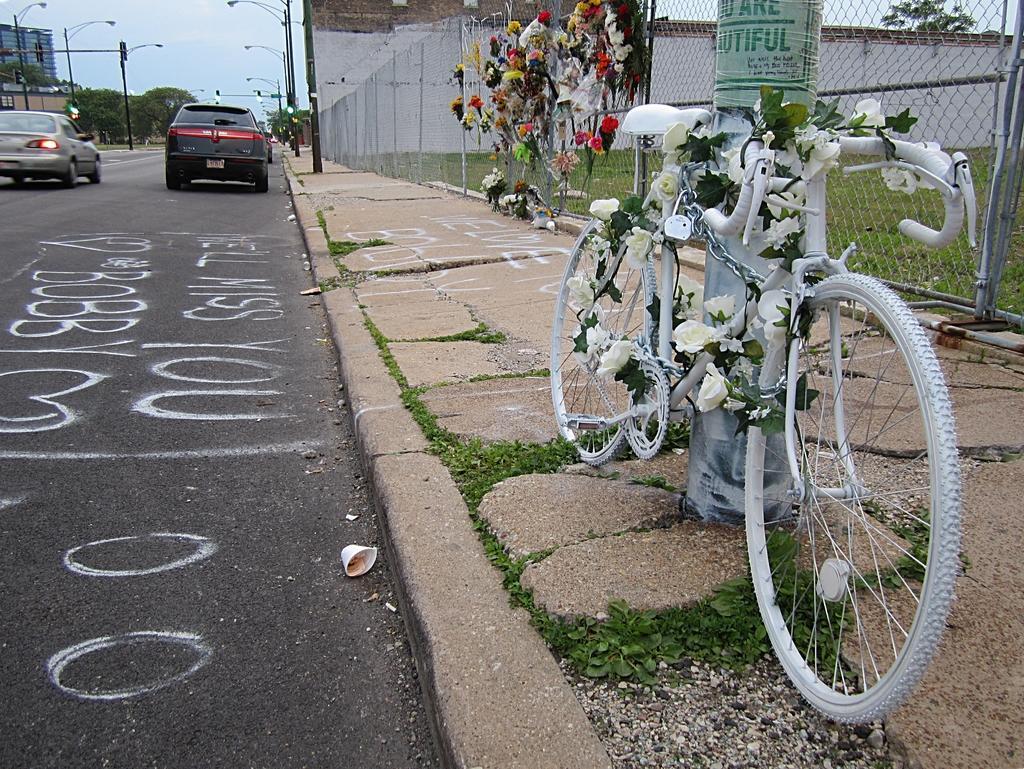Describe this image in one or two sentences. There is a road. On the road there are vehicles. Near to the road there is a sidewalk. On that there is a cycle with flower decoration. Also there is a mesh fencing. On that there are flower bouquets. In the back there are light poles, sky and trees. 